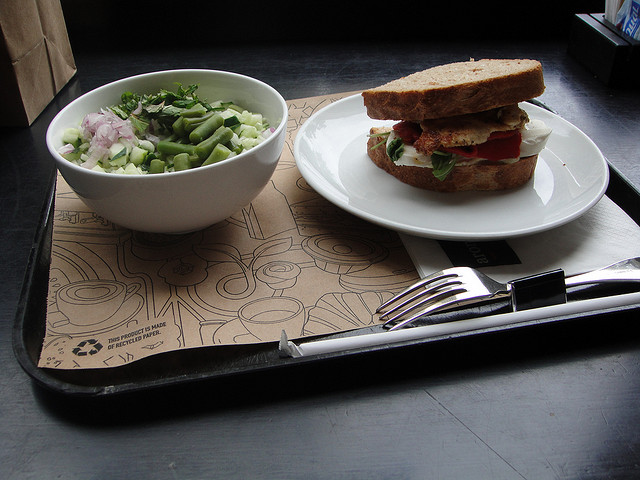Identify and read out the text in this image. PRODUCT 